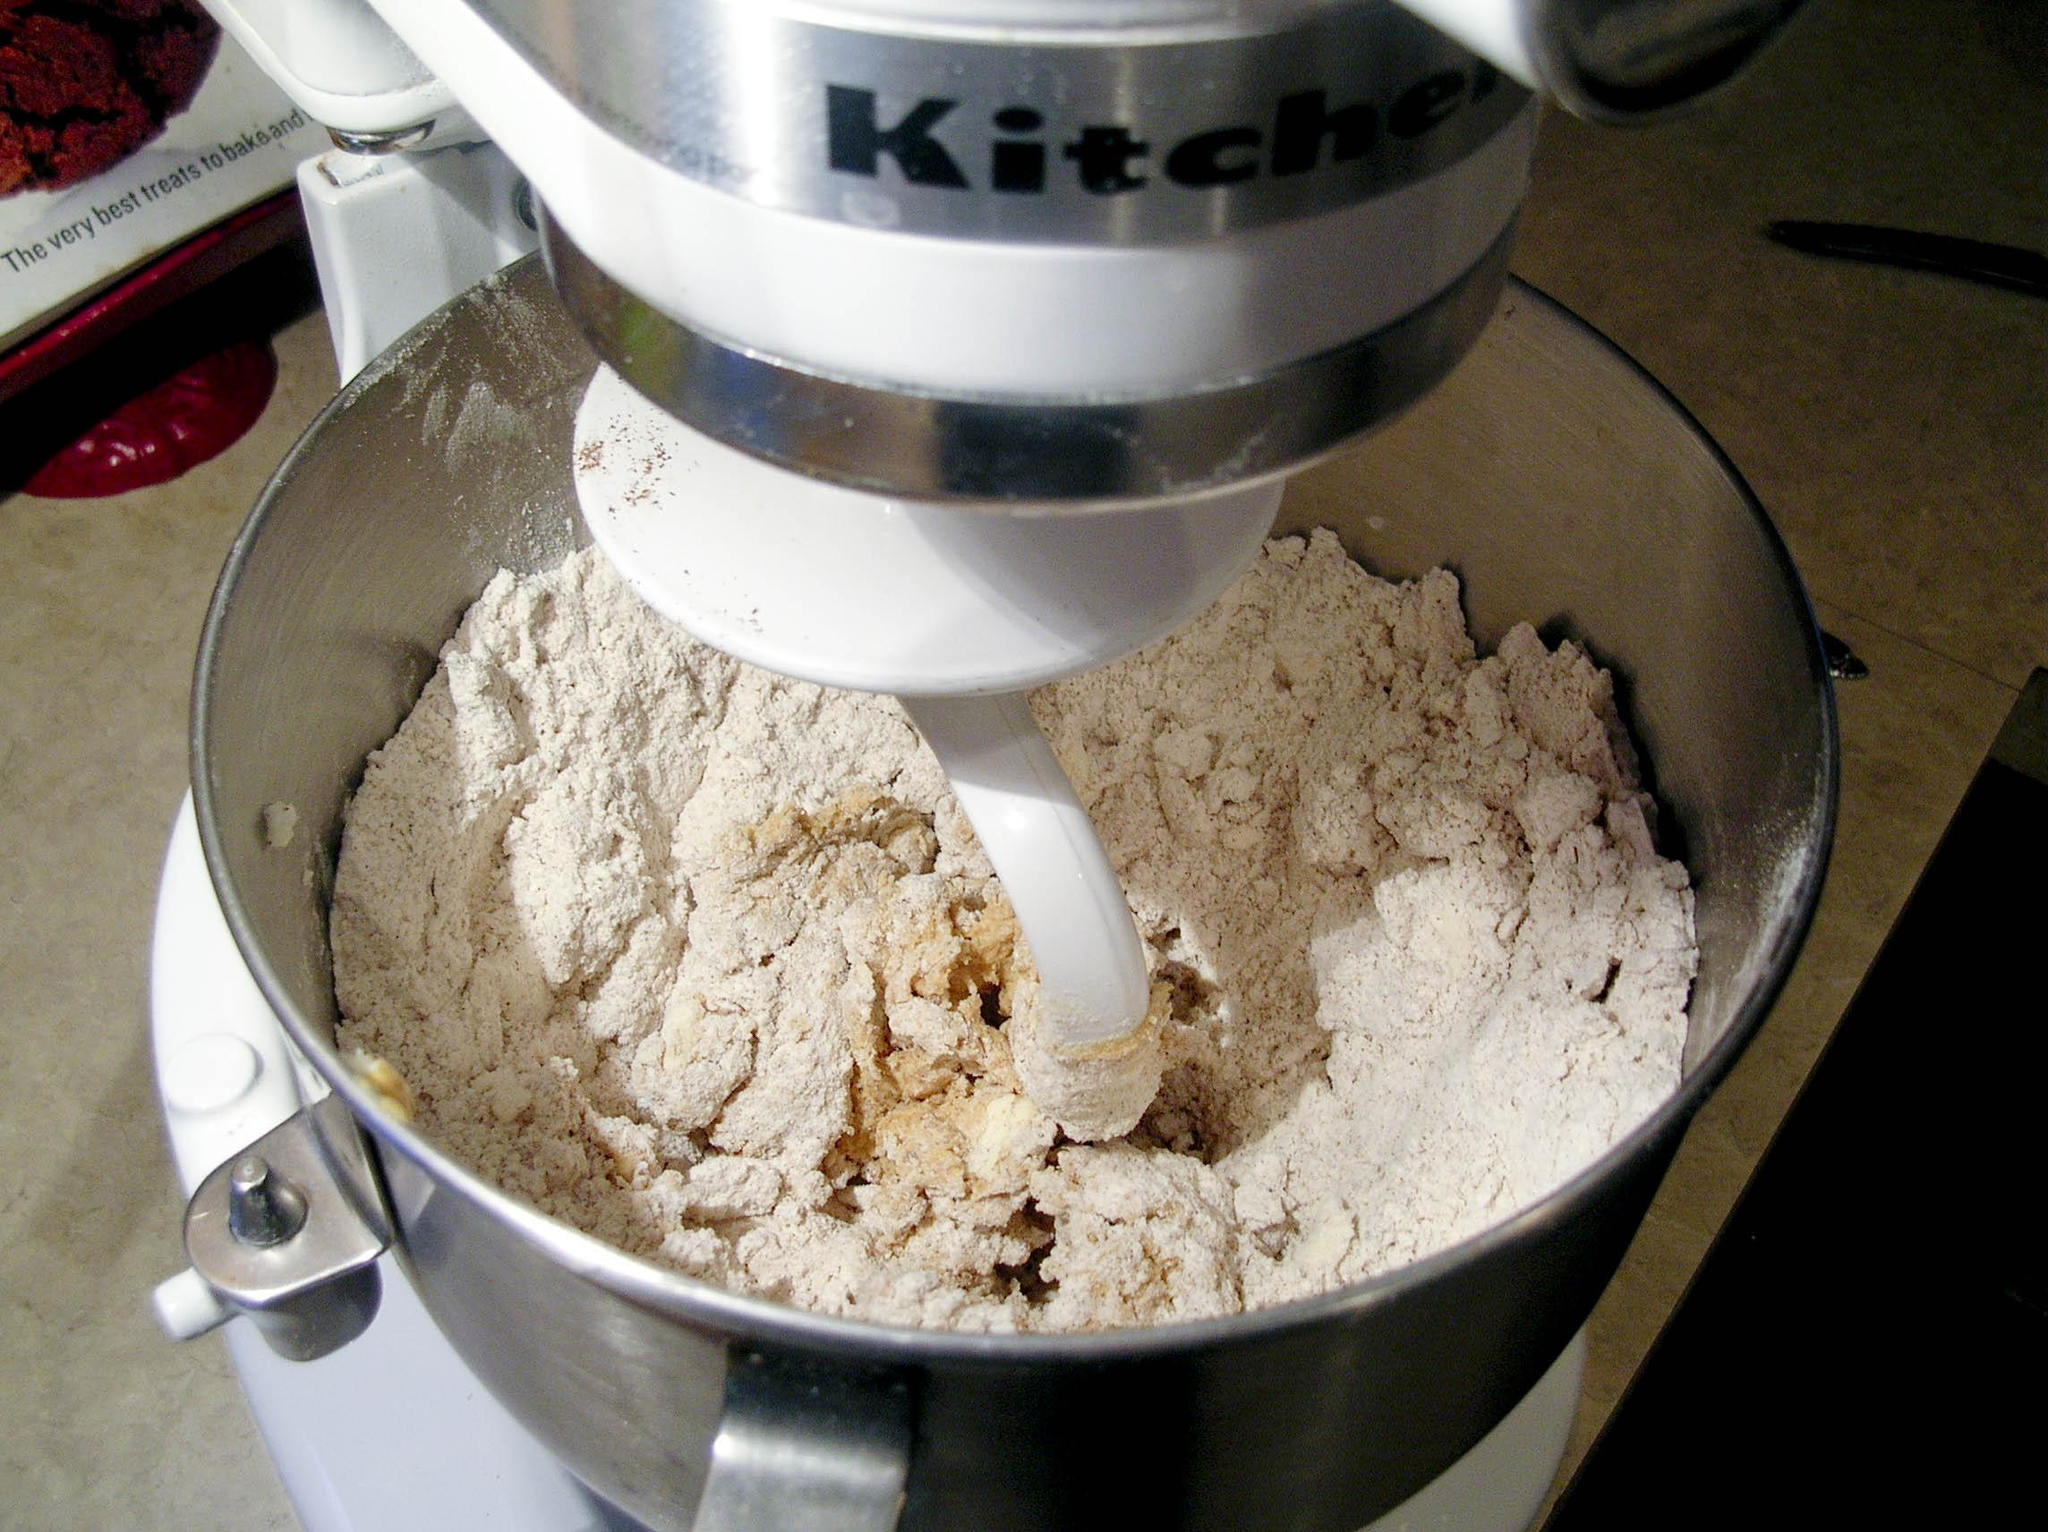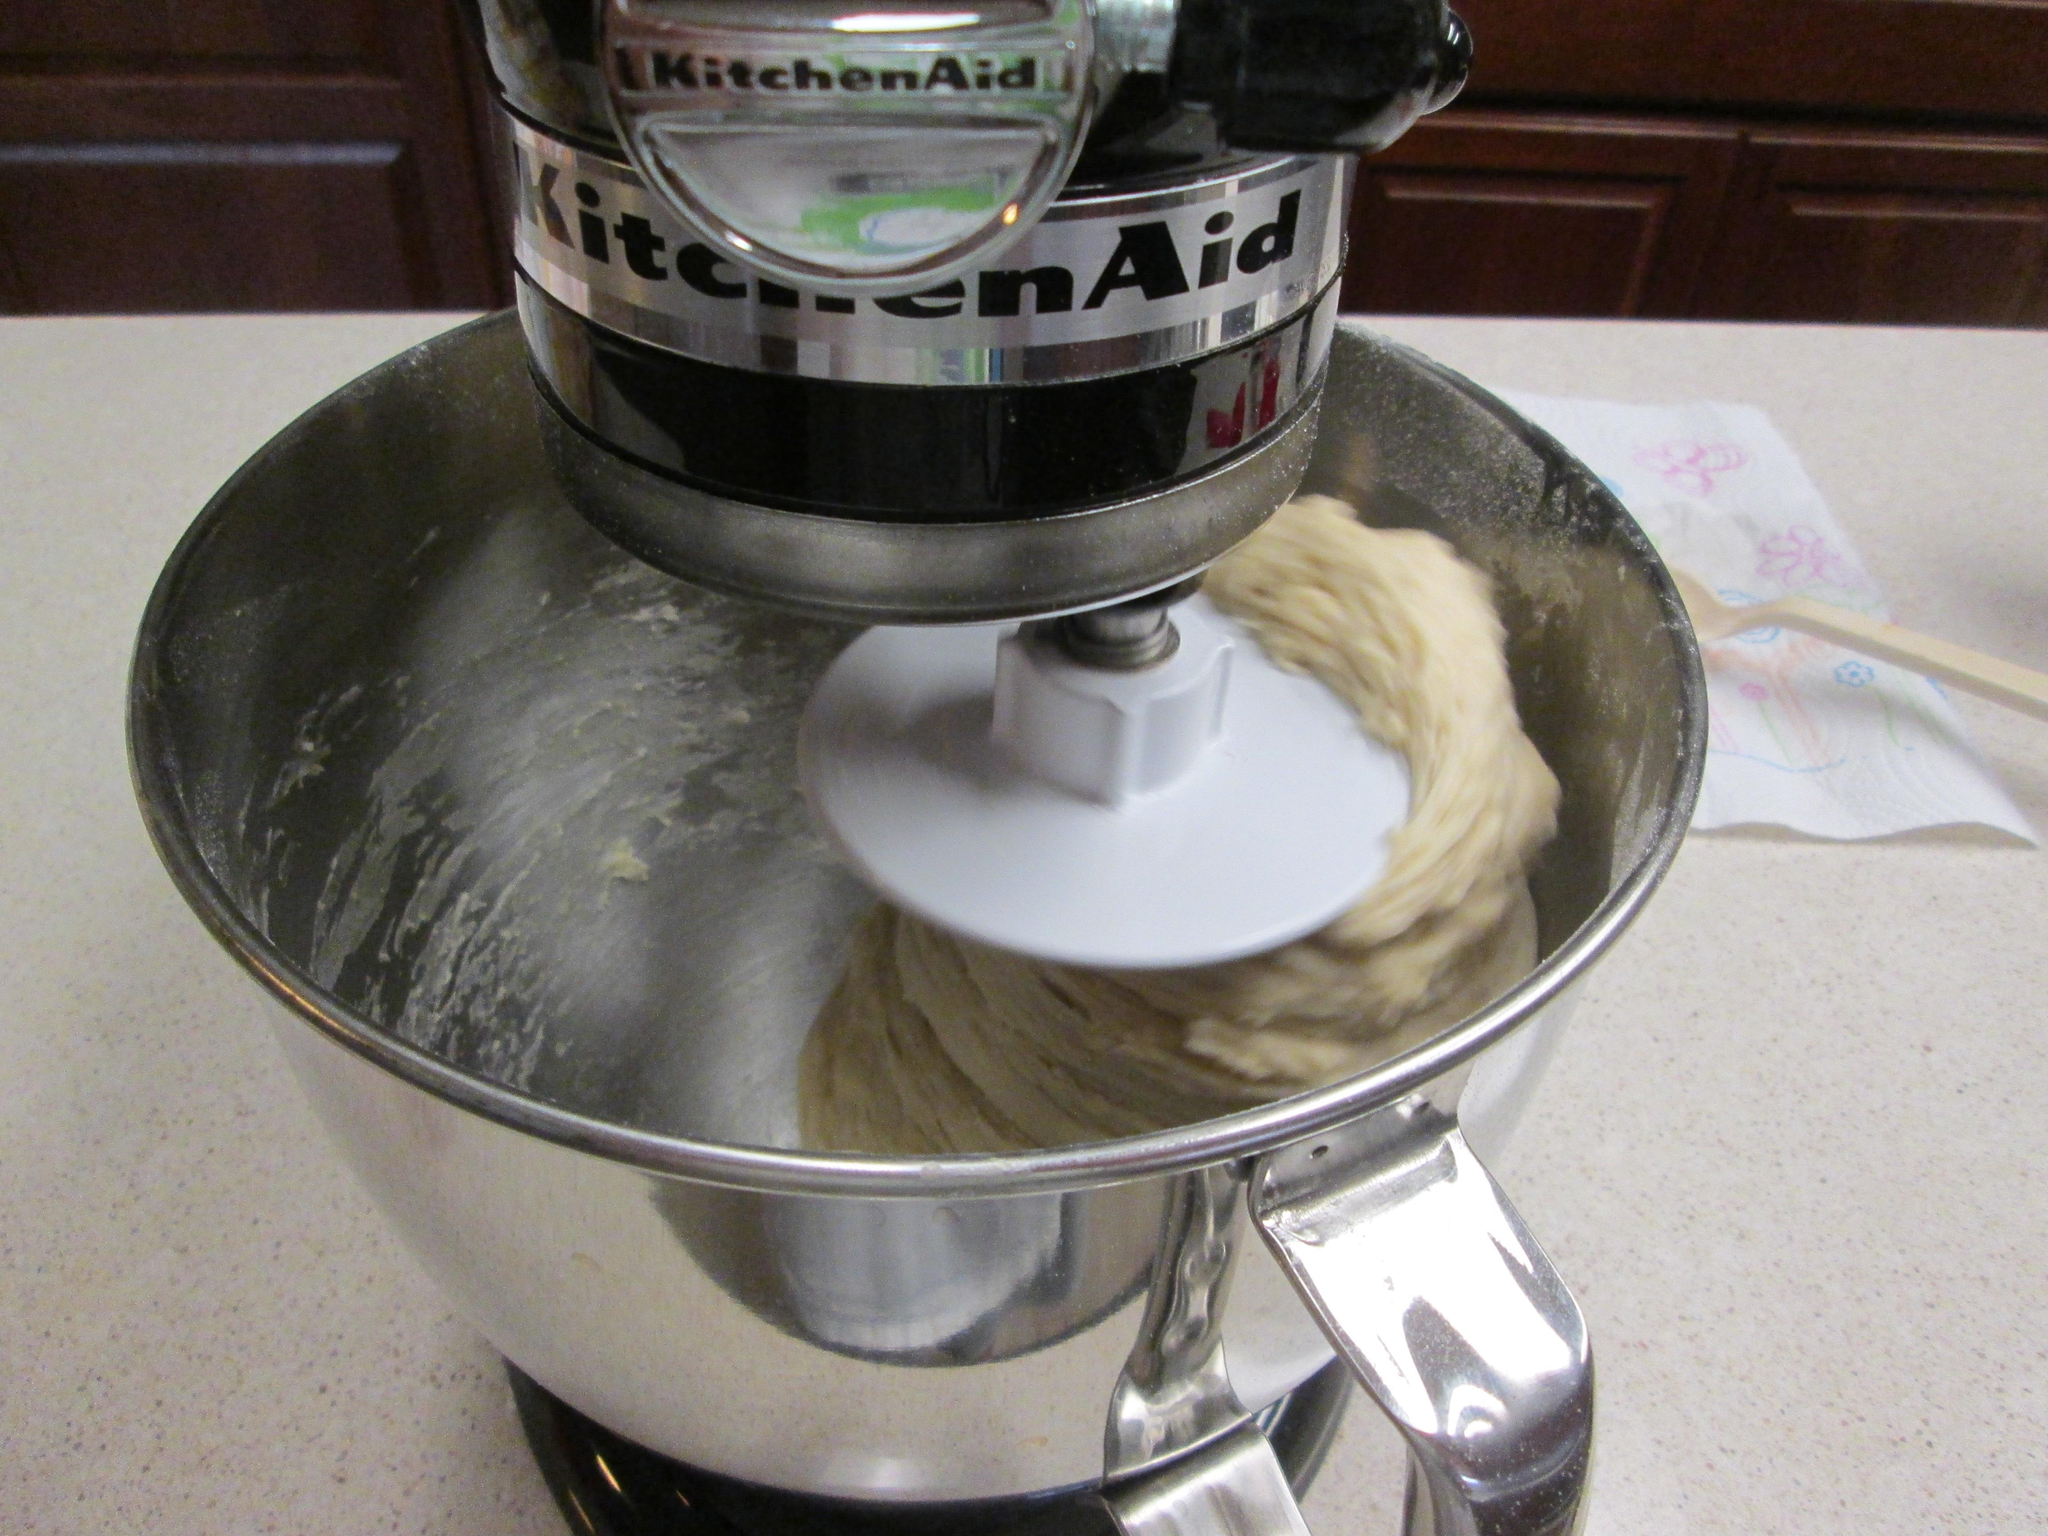The first image is the image on the left, the second image is the image on the right. Assess this claim about the two images: "Each image shows a beater in a bowl of dough, but one image features a solid disk-shaped white beater blade and the other features a bar-shaped white blade.". Correct or not? Answer yes or no. Yes. The first image is the image on the left, the second image is the image on the right. Given the left and right images, does the statement "IN at least one image there is a black and silver kitchenaid  kneading dough." hold true? Answer yes or no. Yes. 